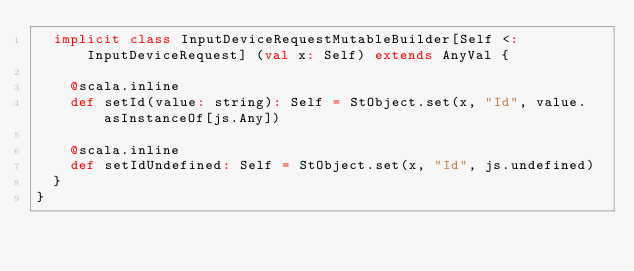<code> <loc_0><loc_0><loc_500><loc_500><_Scala_>  implicit class InputDeviceRequestMutableBuilder[Self <: InputDeviceRequest] (val x: Self) extends AnyVal {
    
    @scala.inline
    def setId(value: string): Self = StObject.set(x, "Id", value.asInstanceOf[js.Any])
    
    @scala.inline
    def setIdUndefined: Self = StObject.set(x, "Id", js.undefined)
  }
}
</code> 